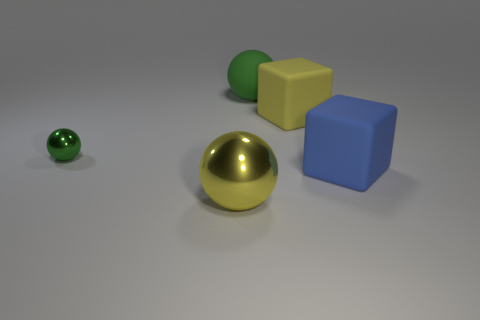Subtract all tiny balls. How many balls are left? 2 Subtract all yellow balls. How many balls are left? 2 Add 3 small metal spheres. How many objects exist? 8 Subtract 1 balls. How many balls are left? 2 Subtract all red spheres. Subtract all cyan cylinders. How many spheres are left? 3 Add 3 big rubber objects. How many big rubber objects exist? 6 Subtract 0 blue cylinders. How many objects are left? 5 Subtract all cubes. How many objects are left? 3 Subtract all green spheres. How many blue cubes are left? 1 Subtract all green metallic objects. Subtract all big yellow shiny objects. How many objects are left? 3 